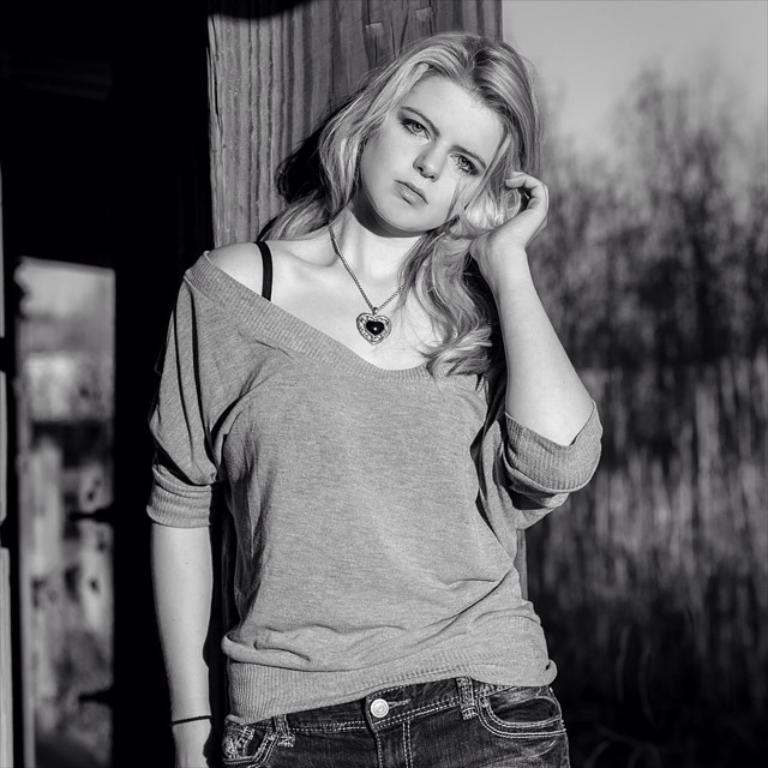Who is the main subject in the image? There is a woman standing in the center of the image. What can be seen in the background of the image? There is a house, trees, and the sky visible in the background of the image. What type of kitty is the woman holding in the image? There is no kitty present in the image; the woman is standing alone in the center. 